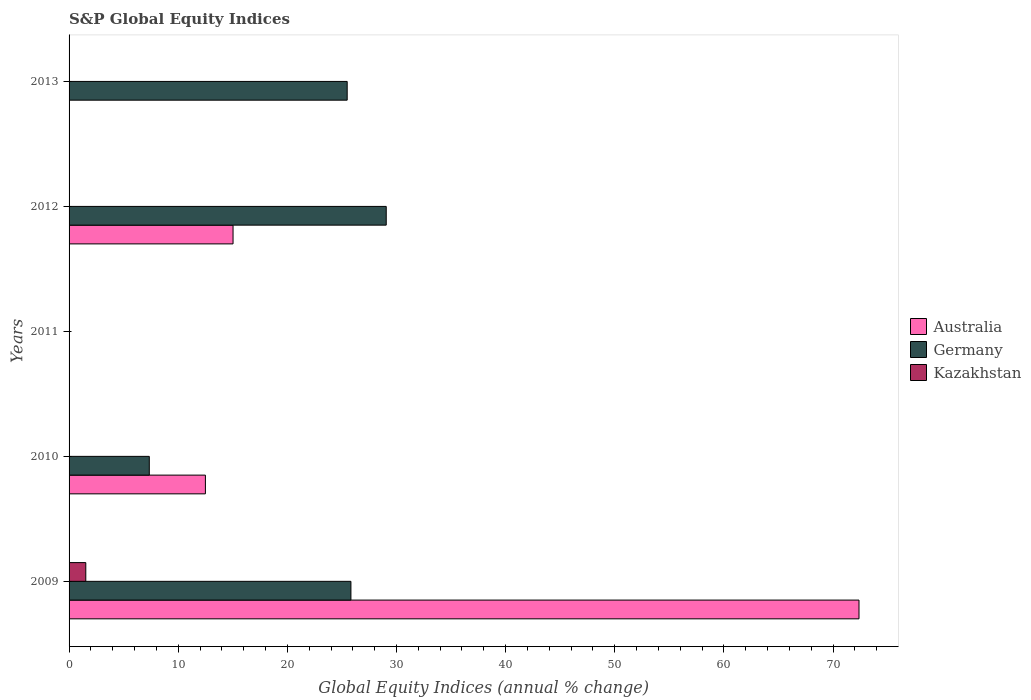How many different coloured bars are there?
Provide a short and direct response. 3. Are the number of bars per tick equal to the number of legend labels?
Your answer should be compact. No. What is the label of the 5th group of bars from the top?
Offer a terse response. 2009. What is the global equity indices in Germany in 2012?
Make the answer very short. 29.06. Across all years, what is the maximum global equity indices in Kazakhstan?
Give a very brief answer. 1.53. What is the total global equity indices in Germany in the graph?
Your response must be concise. 87.72. What is the difference between the global equity indices in Germany in 2012 and that in 2013?
Ensure brevity in your answer.  3.58. What is the difference between the global equity indices in Kazakhstan in 2011 and the global equity indices in Australia in 2012?
Give a very brief answer. -15.02. What is the average global equity indices in Kazakhstan per year?
Make the answer very short. 0.31. In the year 2012, what is the difference between the global equity indices in Germany and global equity indices in Australia?
Give a very brief answer. 14.04. What is the ratio of the global equity indices in Germany in 2009 to that in 2012?
Provide a short and direct response. 0.89. Is the global equity indices in Germany in 2010 less than that in 2012?
Give a very brief answer. Yes. What is the difference between the highest and the second highest global equity indices in Germany?
Keep it short and to the point. 3.24. What is the difference between the highest and the lowest global equity indices in Australia?
Make the answer very short. 72.37. In how many years, is the global equity indices in Australia greater than the average global equity indices in Australia taken over all years?
Make the answer very short. 1. Is it the case that in every year, the sum of the global equity indices in Germany and global equity indices in Australia is greater than the global equity indices in Kazakhstan?
Your answer should be compact. No. How many bars are there?
Your answer should be very brief. 8. Are the values on the major ticks of X-axis written in scientific E-notation?
Give a very brief answer. No. Does the graph contain grids?
Offer a very short reply. No. How are the legend labels stacked?
Provide a short and direct response. Vertical. What is the title of the graph?
Your answer should be compact. S&P Global Equity Indices. Does "Nigeria" appear as one of the legend labels in the graph?
Your response must be concise. No. What is the label or title of the X-axis?
Your answer should be compact. Global Equity Indices (annual % change). What is the label or title of the Y-axis?
Your response must be concise. Years. What is the Global Equity Indices (annual % change) of Australia in 2009?
Keep it short and to the point. 72.37. What is the Global Equity Indices (annual % change) in Germany in 2009?
Provide a short and direct response. 25.82. What is the Global Equity Indices (annual % change) in Kazakhstan in 2009?
Provide a short and direct response. 1.53. What is the Global Equity Indices (annual % change) in Australia in 2010?
Ensure brevity in your answer.  12.49. What is the Global Equity Indices (annual % change) of Germany in 2010?
Make the answer very short. 7.35. What is the Global Equity Indices (annual % change) in Australia in 2012?
Keep it short and to the point. 15.02. What is the Global Equity Indices (annual % change) in Germany in 2012?
Your answer should be compact. 29.06. What is the Global Equity Indices (annual % change) in Kazakhstan in 2012?
Your response must be concise. 0. What is the Global Equity Indices (annual % change) of Australia in 2013?
Your answer should be very brief. 0. What is the Global Equity Indices (annual % change) of Germany in 2013?
Your answer should be very brief. 25.48. Across all years, what is the maximum Global Equity Indices (annual % change) in Australia?
Your answer should be compact. 72.37. Across all years, what is the maximum Global Equity Indices (annual % change) in Germany?
Give a very brief answer. 29.06. Across all years, what is the maximum Global Equity Indices (annual % change) in Kazakhstan?
Your response must be concise. 1.53. Across all years, what is the minimum Global Equity Indices (annual % change) in Australia?
Your answer should be very brief. 0. What is the total Global Equity Indices (annual % change) of Australia in the graph?
Keep it short and to the point. 99.89. What is the total Global Equity Indices (annual % change) in Germany in the graph?
Keep it short and to the point. 87.72. What is the total Global Equity Indices (annual % change) in Kazakhstan in the graph?
Your answer should be compact. 1.53. What is the difference between the Global Equity Indices (annual % change) of Australia in 2009 and that in 2010?
Ensure brevity in your answer.  59.88. What is the difference between the Global Equity Indices (annual % change) of Germany in 2009 and that in 2010?
Your answer should be compact. 18.47. What is the difference between the Global Equity Indices (annual % change) in Australia in 2009 and that in 2012?
Provide a succinct answer. 57.35. What is the difference between the Global Equity Indices (annual % change) in Germany in 2009 and that in 2012?
Keep it short and to the point. -3.24. What is the difference between the Global Equity Indices (annual % change) in Germany in 2009 and that in 2013?
Give a very brief answer. 0.34. What is the difference between the Global Equity Indices (annual % change) of Australia in 2010 and that in 2012?
Your answer should be very brief. -2.53. What is the difference between the Global Equity Indices (annual % change) of Germany in 2010 and that in 2012?
Provide a short and direct response. -21.71. What is the difference between the Global Equity Indices (annual % change) in Germany in 2010 and that in 2013?
Ensure brevity in your answer.  -18.13. What is the difference between the Global Equity Indices (annual % change) in Germany in 2012 and that in 2013?
Provide a succinct answer. 3.58. What is the difference between the Global Equity Indices (annual % change) of Australia in 2009 and the Global Equity Indices (annual % change) of Germany in 2010?
Your answer should be very brief. 65.02. What is the difference between the Global Equity Indices (annual % change) of Australia in 2009 and the Global Equity Indices (annual % change) of Germany in 2012?
Offer a terse response. 43.31. What is the difference between the Global Equity Indices (annual % change) of Australia in 2009 and the Global Equity Indices (annual % change) of Germany in 2013?
Your answer should be compact. 46.89. What is the difference between the Global Equity Indices (annual % change) of Australia in 2010 and the Global Equity Indices (annual % change) of Germany in 2012?
Give a very brief answer. -16.57. What is the difference between the Global Equity Indices (annual % change) in Australia in 2010 and the Global Equity Indices (annual % change) in Germany in 2013?
Offer a terse response. -12.99. What is the difference between the Global Equity Indices (annual % change) of Australia in 2012 and the Global Equity Indices (annual % change) of Germany in 2013?
Make the answer very short. -10.46. What is the average Global Equity Indices (annual % change) of Australia per year?
Give a very brief answer. 19.98. What is the average Global Equity Indices (annual % change) in Germany per year?
Keep it short and to the point. 17.54. What is the average Global Equity Indices (annual % change) in Kazakhstan per year?
Make the answer very short. 0.31. In the year 2009, what is the difference between the Global Equity Indices (annual % change) in Australia and Global Equity Indices (annual % change) in Germany?
Offer a very short reply. 46.55. In the year 2009, what is the difference between the Global Equity Indices (annual % change) of Australia and Global Equity Indices (annual % change) of Kazakhstan?
Provide a short and direct response. 70.84. In the year 2009, what is the difference between the Global Equity Indices (annual % change) of Germany and Global Equity Indices (annual % change) of Kazakhstan?
Your answer should be very brief. 24.29. In the year 2010, what is the difference between the Global Equity Indices (annual % change) of Australia and Global Equity Indices (annual % change) of Germany?
Give a very brief answer. 5.14. In the year 2012, what is the difference between the Global Equity Indices (annual % change) of Australia and Global Equity Indices (annual % change) of Germany?
Offer a terse response. -14.04. What is the ratio of the Global Equity Indices (annual % change) in Australia in 2009 to that in 2010?
Offer a terse response. 5.79. What is the ratio of the Global Equity Indices (annual % change) in Germany in 2009 to that in 2010?
Offer a terse response. 3.51. What is the ratio of the Global Equity Indices (annual % change) in Australia in 2009 to that in 2012?
Your answer should be very brief. 4.82. What is the ratio of the Global Equity Indices (annual % change) in Germany in 2009 to that in 2012?
Your answer should be very brief. 0.89. What is the ratio of the Global Equity Indices (annual % change) of Germany in 2009 to that in 2013?
Your response must be concise. 1.01. What is the ratio of the Global Equity Indices (annual % change) of Australia in 2010 to that in 2012?
Provide a succinct answer. 0.83. What is the ratio of the Global Equity Indices (annual % change) in Germany in 2010 to that in 2012?
Your answer should be compact. 0.25. What is the ratio of the Global Equity Indices (annual % change) of Germany in 2010 to that in 2013?
Ensure brevity in your answer.  0.29. What is the ratio of the Global Equity Indices (annual % change) of Germany in 2012 to that in 2013?
Keep it short and to the point. 1.14. What is the difference between the highest and the second highest Global Equity Indices (annual % change) of Australia?
Provide a succinct answer. 57.35. What is the difference between the highest and the second highest Global Equity Indices (annual % change) of Germany?
Ensure brevity in your answer.  3.24. What is the difference between the highest and the lowest Global Equity Indices (annual % change) of Australia?
Your answer should be very brief. 72.37. What is the difference between the highest and the lowest Global Equity Indices (annual % change) of Germany?
Your answer should be compact. 29.06. What is the difference between the highest and the lowest Global Equity Indices (annual % change) in Kazakhstan?
Provide a short and direct response. 1.53. 